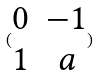<formula> <loc_0><loc_0><loc_500><loc_500>( \begin{matrix} 0 & - 1 \\ 1 & a \\ \end{matrix} )</formula> 